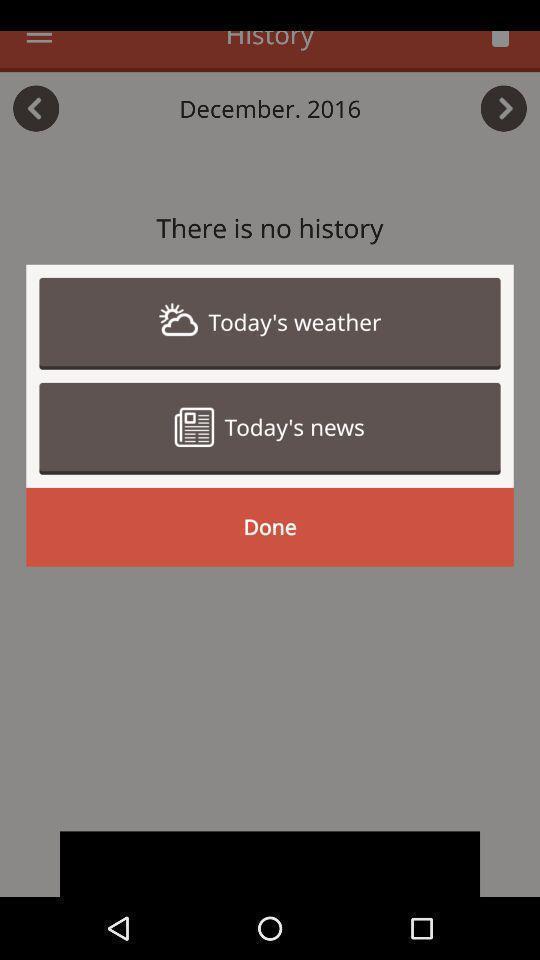Provide a textual representation of this image. Popup to choose news or weather in a news app. 